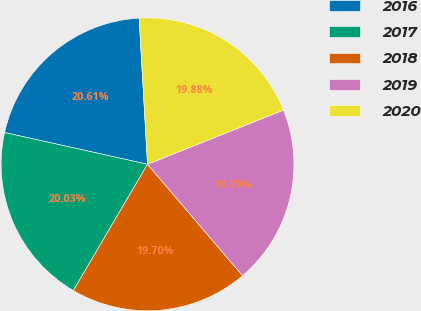<chart> <loc_0><loc_0><loc_500><loc_500><pie_chart><fcel>2016<fcel>2017<fcel>2018<fcel>2019<fcel>2020<nl><fcel>20.61%<fcel>20.03%<fcel>19.7%<fcel>19.79%<fcel>19.88%<nl></chart> 